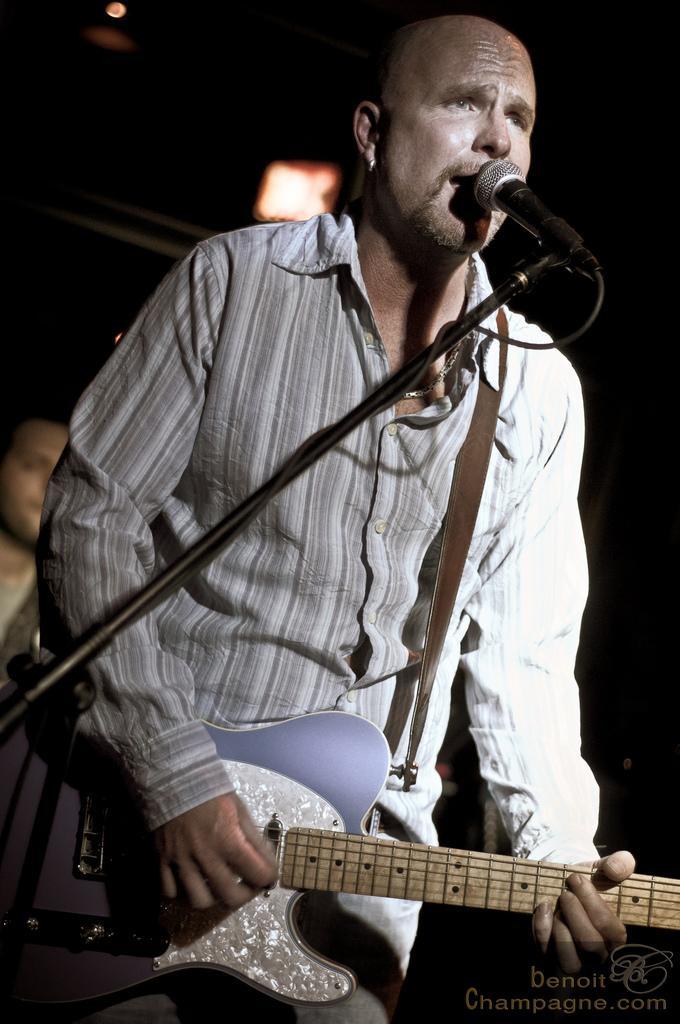In one or two sentences, can you explain what this image depicts? In this image we have a man standing and playing a guitar by singing a song in the microphone and at the back ground we have another person. 